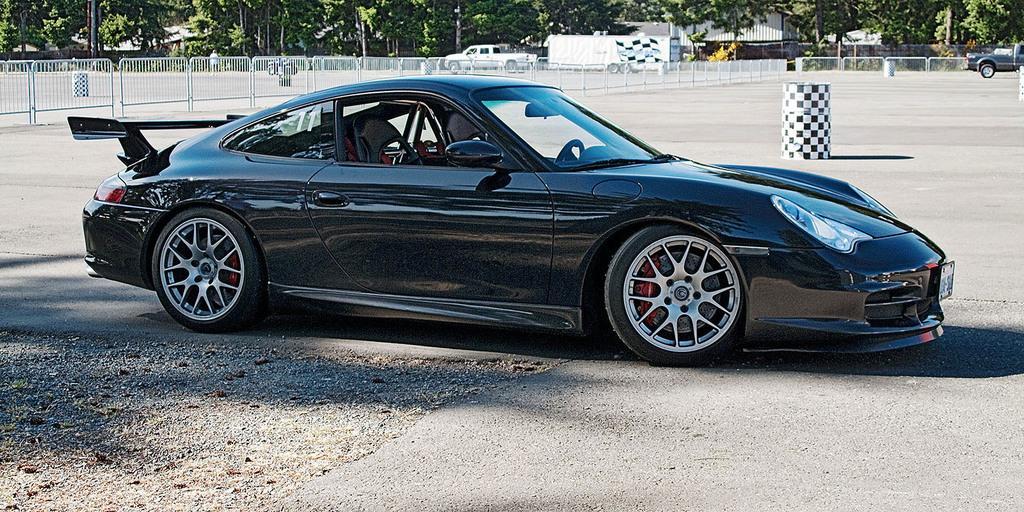Could you give a brief overview of what you see in this image? In the foreground of the picture there is a car on the road. In the background there are fencing, drums, vehicles, trees and buildings. 